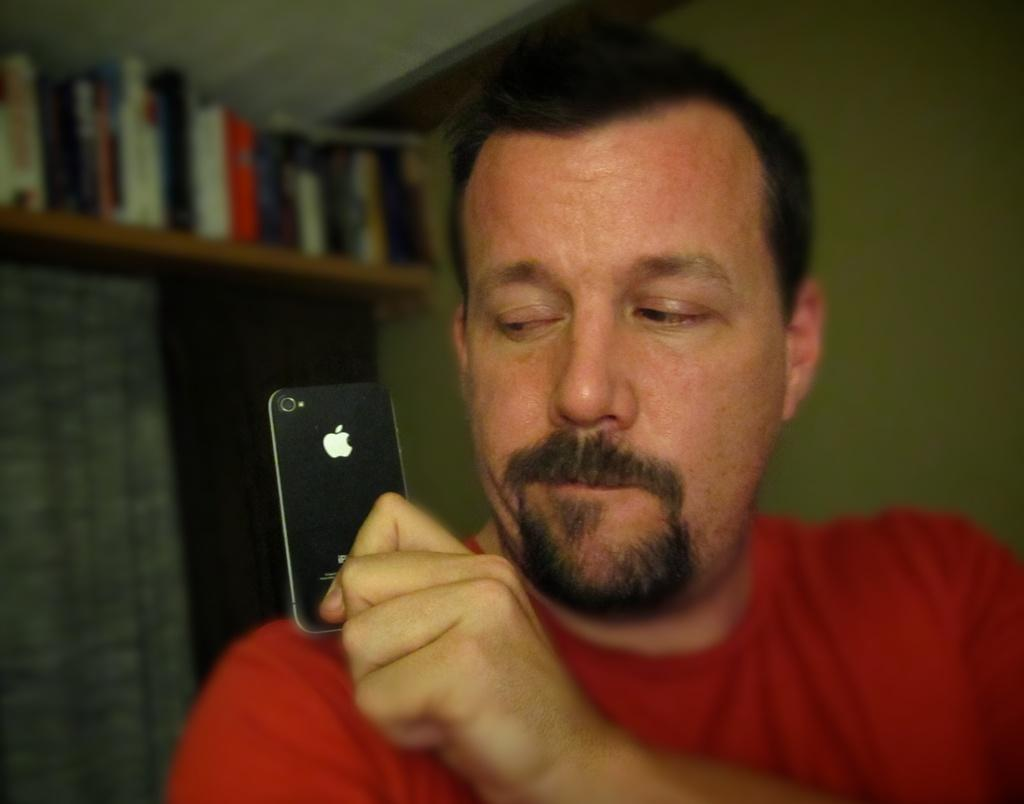Who is present in the image? There is a man in the image. What is the man holding in the image? The man is holding a mobile in the image. What is the color of the mobile? The mobile is black in color. What can be seen in the background of the image? There are books and a wall in the background of the image. Where are the books located in the image? The books are on a shelf in the background of the image. What is the color of the wall in the image? The wall is white in color. What type of frame is used for the committee meeting in the image? There is no committee meeting or frame present in the image; it features a man holding a black mobile in front of a white wall with books on a shelf in the background. 